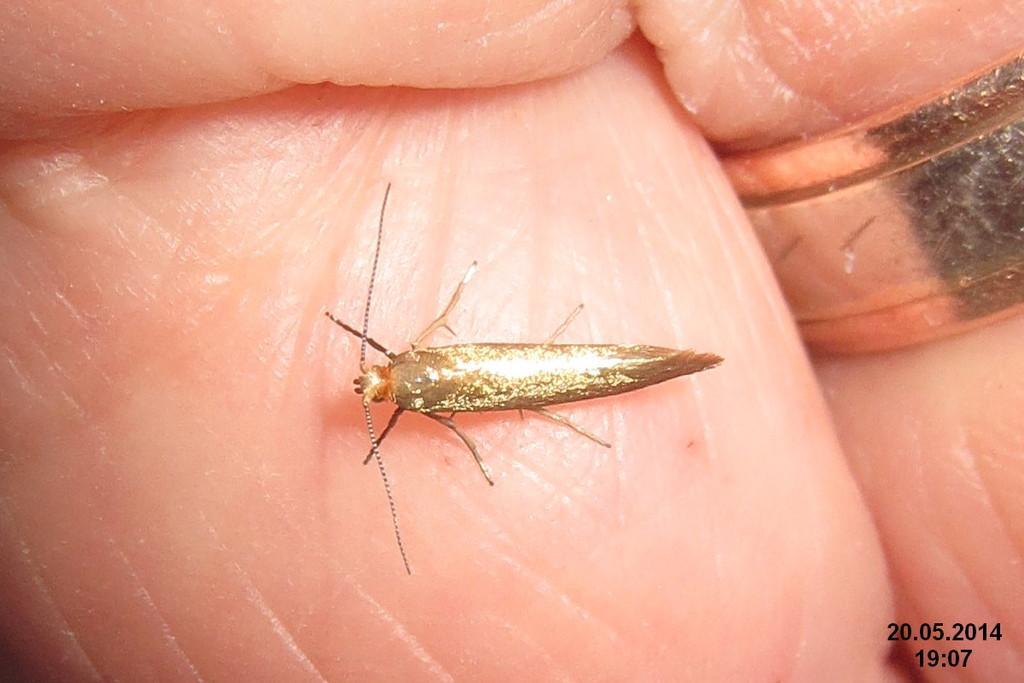Describe this image in one or two sentences. In the image there is an insect on the skin. And also there is a ring. In the bottom right corner of the image there is time and date. 